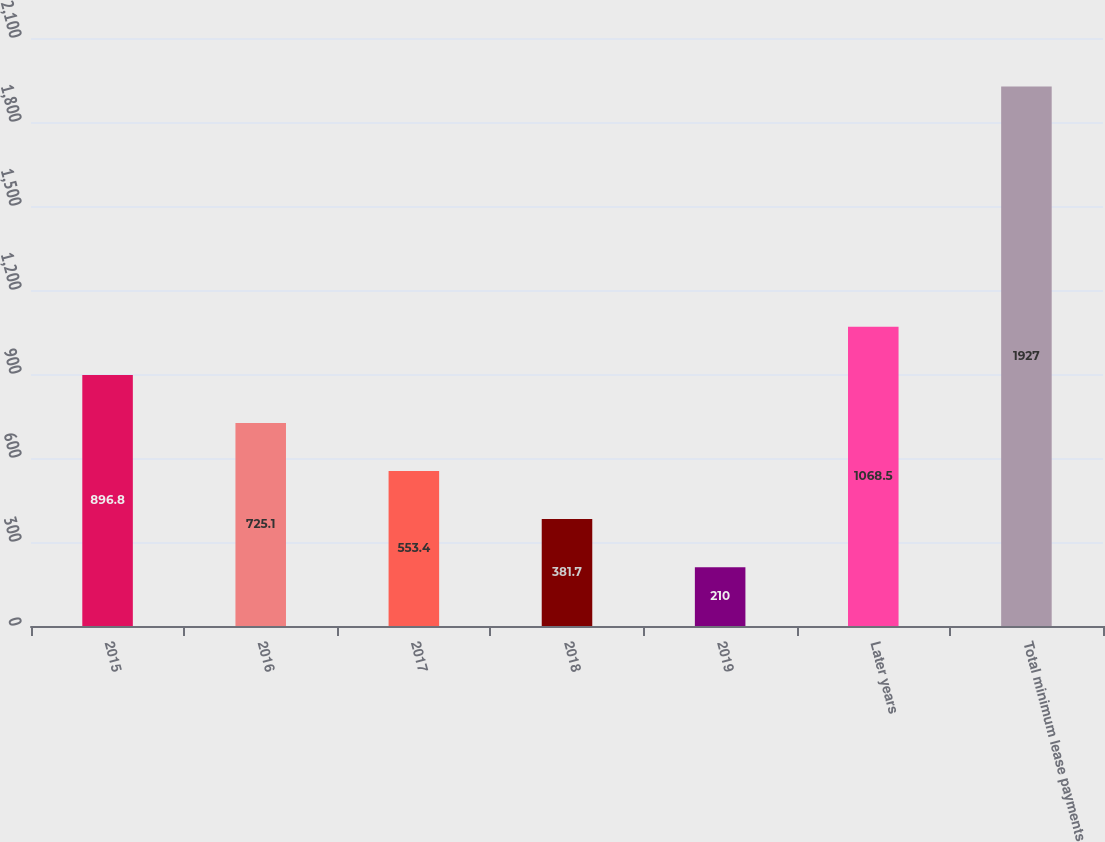Convert chart. <chart><loc_0><loc_0><loc_500><loc_500><bar_chart><fcel>2015<fcel>2016<fcel>2017<fcel>2018<fcel>2019<fcel>Later years<fcel>Total minimum lease payments<nl><fcel>896.8<fcel>725.1<fcel>553.4<fcel>381.7<fcel>210<fcel>1068.5<fcel>1927<nl></chart> 